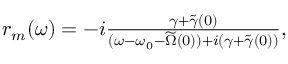Convert formula to latex. <formula><loc_0><loc_0><loc_500><loc_500>\begin{array} { r } { r _ { m } ( \omega ) = - i \frac { \gamma + \widetilde { \gamma } ( 0 ) } { ( \omega - \omega _ { 0 } - \widetilde { \Omega } ( 0 ) ) + i ( \gamma + \widetilde { \gamma } ( 0 ) ) } , } \end{array}</formula> 